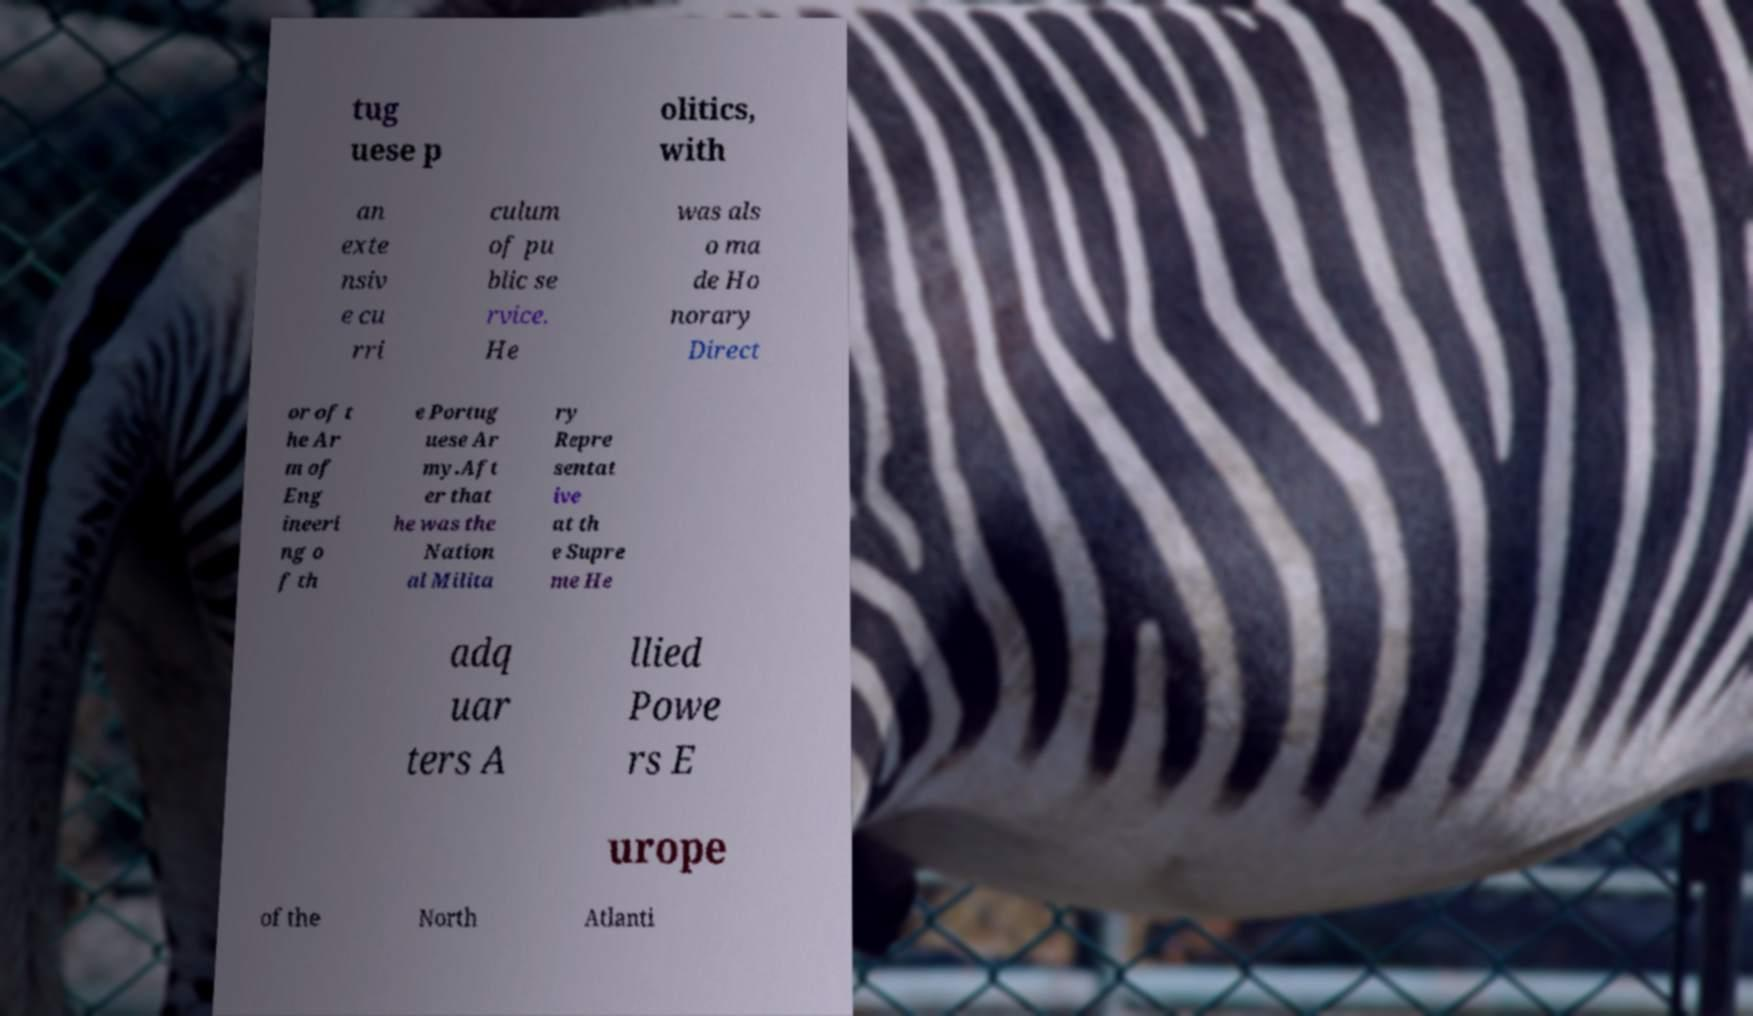There's text embedded in this image that I need extracted. Can you transcribe it verbatim? tug uese p olitics, with an exte nsiv e cu rri culum of pu blic se rvice. He was als o ma de Ho norary Direct or of t he Ar m of Eng ineeri ng o f th e Portug uese Ar my.Aft er that he was the Nation al Milita ry Repre sentat ive at th e Supre me He adq uar ters A llied Powe rs E urope of the North Atlanti 